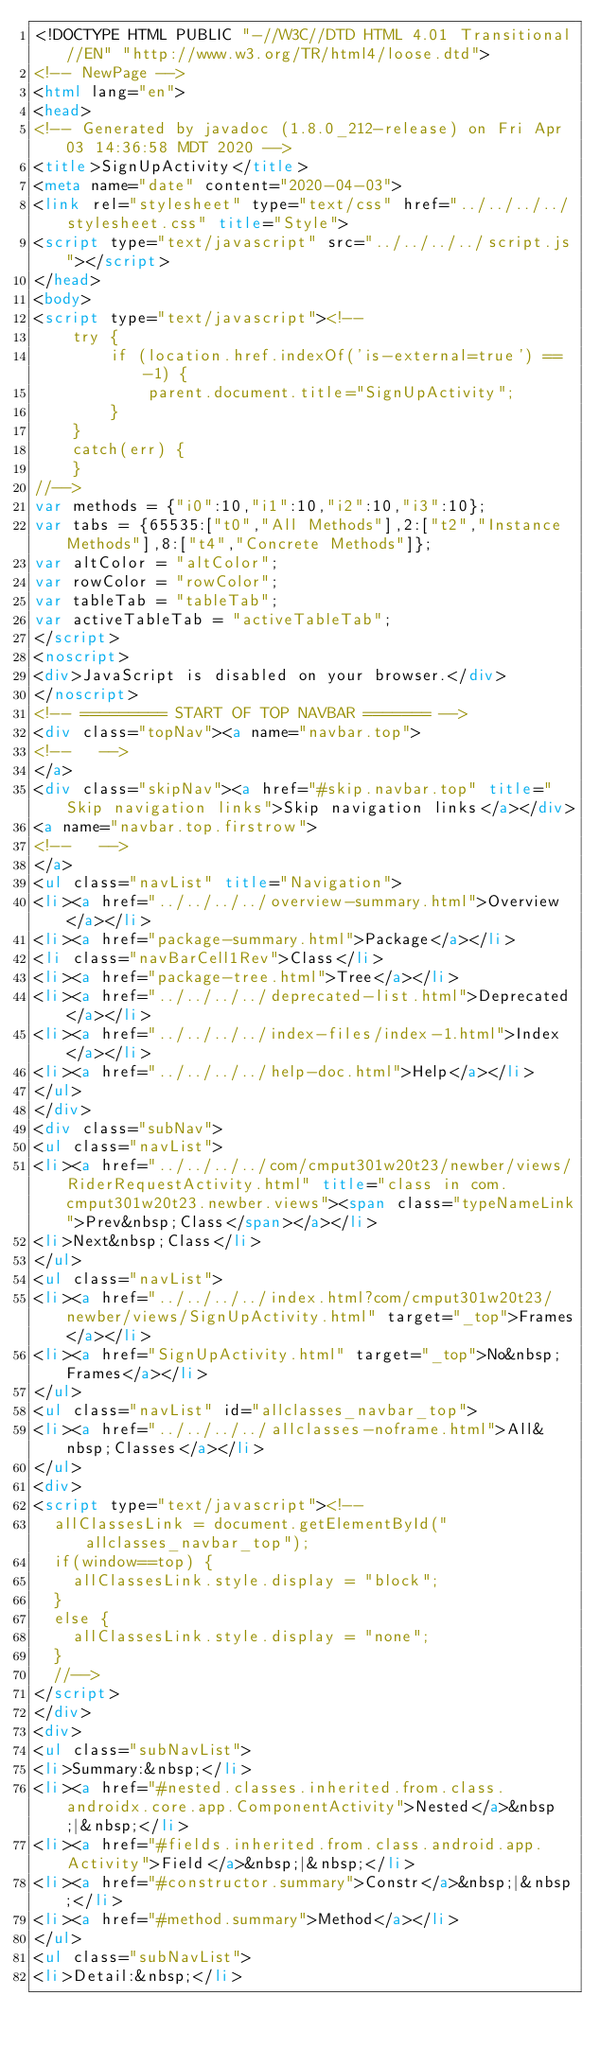<code> <loc_0><loc_0><loc_500><loc_500><_HTML_><!DOCTYPE HTML PUBLIC "-//W3C//DTD HTML 4.01 Transitional//EN" "http://www.w3.org/TR/html4/loose.dtd">
<!-- NewPage -->
<html lang="en">
<head>
<!-- Generated by javadoc (1.8.0_212-release) on Fri Apr 03 14:36:58 MDT 2020 -->
<title>SignUpActivity</title>
<meta name="date" content="2020-04-03">
<link rel="stylesheet" type="text/css" href="../../../../stylesheet.css" title="Style">
<script type="text/javascript" src="../../../../script.js"></script>
</head>
<body>
<script type="text/javascript"><!--
    try {
        if (location.href.indexOf('is-external=true') == -1) {
            parent.document.title="SignUpActivity";
        }
    }
    catch(err) {
    }
//-->
var methods = {"i0":10,"i1":10,"i2":10,"i3":10};
var tabs = {65535:["t0","All Methods"],2:["t2","Instance Methods"],8:["t4","Concrete Methods"]};
var altColor = "altColor";
var rowColor = "rowColor";
var tableTab = "tableTab";
var activeTableTab = "activeTableTab";
</script>
<noscript>
<div>JavaScript is disabled on your browser.</div>
</noscript>
<!-- ========= START OF TOP NAVBAR ======= -->
<div class="topNav"><a name="navbar.top">
<!--   -->
</a>
<div class="skipNav"><a href="#skip.navbar.top" title="Skip navigation links">Skip navigation links</a></div>
<a name="navbar.top.firstrow">
<!--   -->
</a>
<ul class="navList" title="Navigation">
<li><a href="../../../../overview-summary.html">Overview</a></li>
<li><a href="package-summary.html">Package</a></li>
<li class="navBarCell1Rev">Class</li>
<li><a href="package-tree.html">Tree</a></li>
<li><a href="../../../../deprecated-list.html">Deprecated</a></li>
<li><a href="../../../../index-files/index-1.html">Index</a></li>
<li><a href="../../../../help-doc.html">Help</a></li>
</ul>
</div>
<div class="subNav">
<ul class="navList">
<li><a href="../../../../com/cmput301w20t23/newber/views/RiderRequestActivity.html" title="class in com.cmput301w20t23.newber.views"><span class="typeNameLink">Prev&nbsp;Class</span></a></li>
<li>Next&nbsp;Class</li>
</ul>
<ul class="navList">
<li><a href="../../../../index.html?com/cmput301w20t23/newber/views/SignUpActivity.html" target="_top">Frames</a></li>
<li><a href="SignUpActivity.html" target="_top">No&nbsp;Frames</a></li>
</ul>
<ul class="navList" id="allclasses_navbar_top">
<li><a href="../../../../allclasses-noframe.html">All&nbsp;Classes</a></li>
</ul>
<div>
<script type="text/javascript"><!--
  allClassesLink = document.getElementById("allclasses_navbar_top");
  if(window==top) {
    allClassesLink.style.display = "block";
  }
  else {
    allClassesLink.style.display = "none";
  }
  //-->
</script>
</div>
<div>
<ul class="subNavList">
<li>Summary:&nbsp;</li>
<li><a href="#nested.classes.inherited.from.class.androidx.core.app.ComponentActivity">Nested</a>&nbsp;|&nbsp;</li>
<li><a href="#fields.inherited.from.class.android.app.Activity">Field</a>&nbsp;|&nbsp;</li>
<li><a href="#constructor.summary">Constr</a>&nbsp;|&nbsp;</li>
<li><a href="#method.summary">Method</a></li>
</ul>
<ul class="subNavList">
<li>Detail:&nbsp;</li></code> 